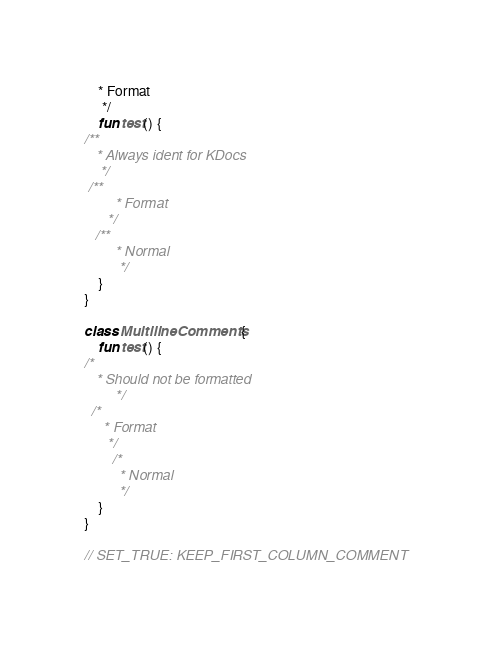Convert code to text. <code><loc_0><loc_0><loc_500><loc_500><_Kotlin_>    * Format
     */
    fun test() {
/**
   * Always ident for KDocs
    */
 /**
        * Format
      */
   /**
        * Normal
         */
    }
}

class MultilineComments {
    fun test() {
/*
   * Should not be formatted
        */
  /*
     * Format
      */
        /*
         * Normal
         */
    }
}

// SET_TRUE: KEEP_FIRST_COLUMN_COMMENT</code> 